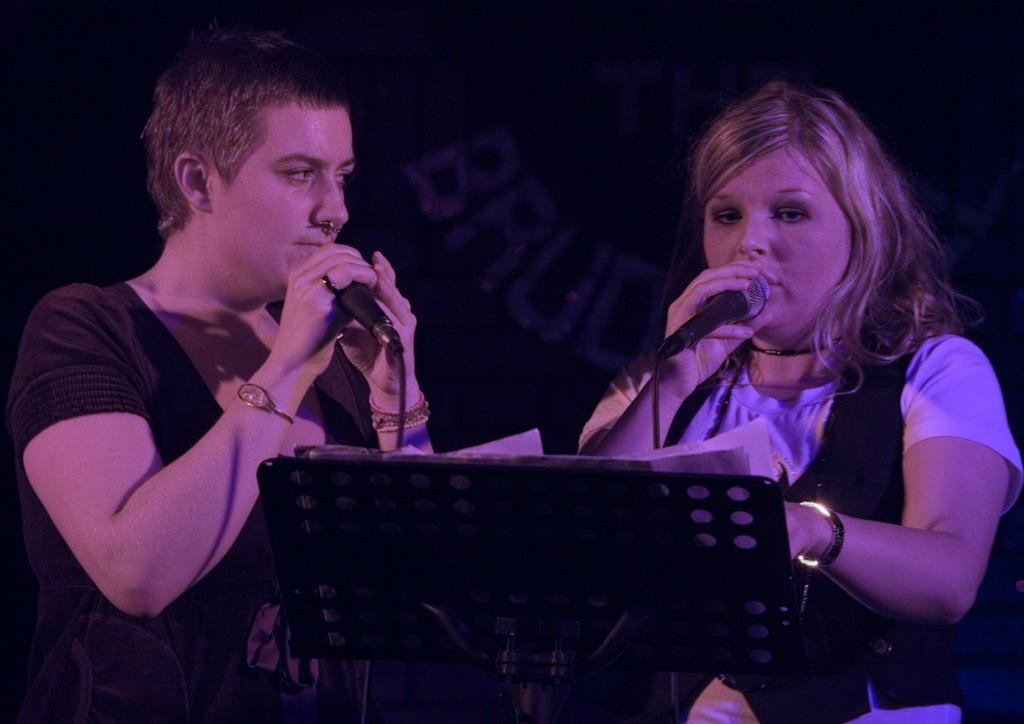Who or what is present in the image? There are people in the image. What are the people holding in their hands? The people are holding microphones. What object can be seen in the image that is often used for speeches or presentations? There is a podium in the image. What is placed on the podium? There are papers on the podium. What can be seen in the background of the image? There is text visible in the background of the image. Can you tell me how many goldfish are swimming in the background of the image? There are no goldfish present in the image; the background features text instead. 